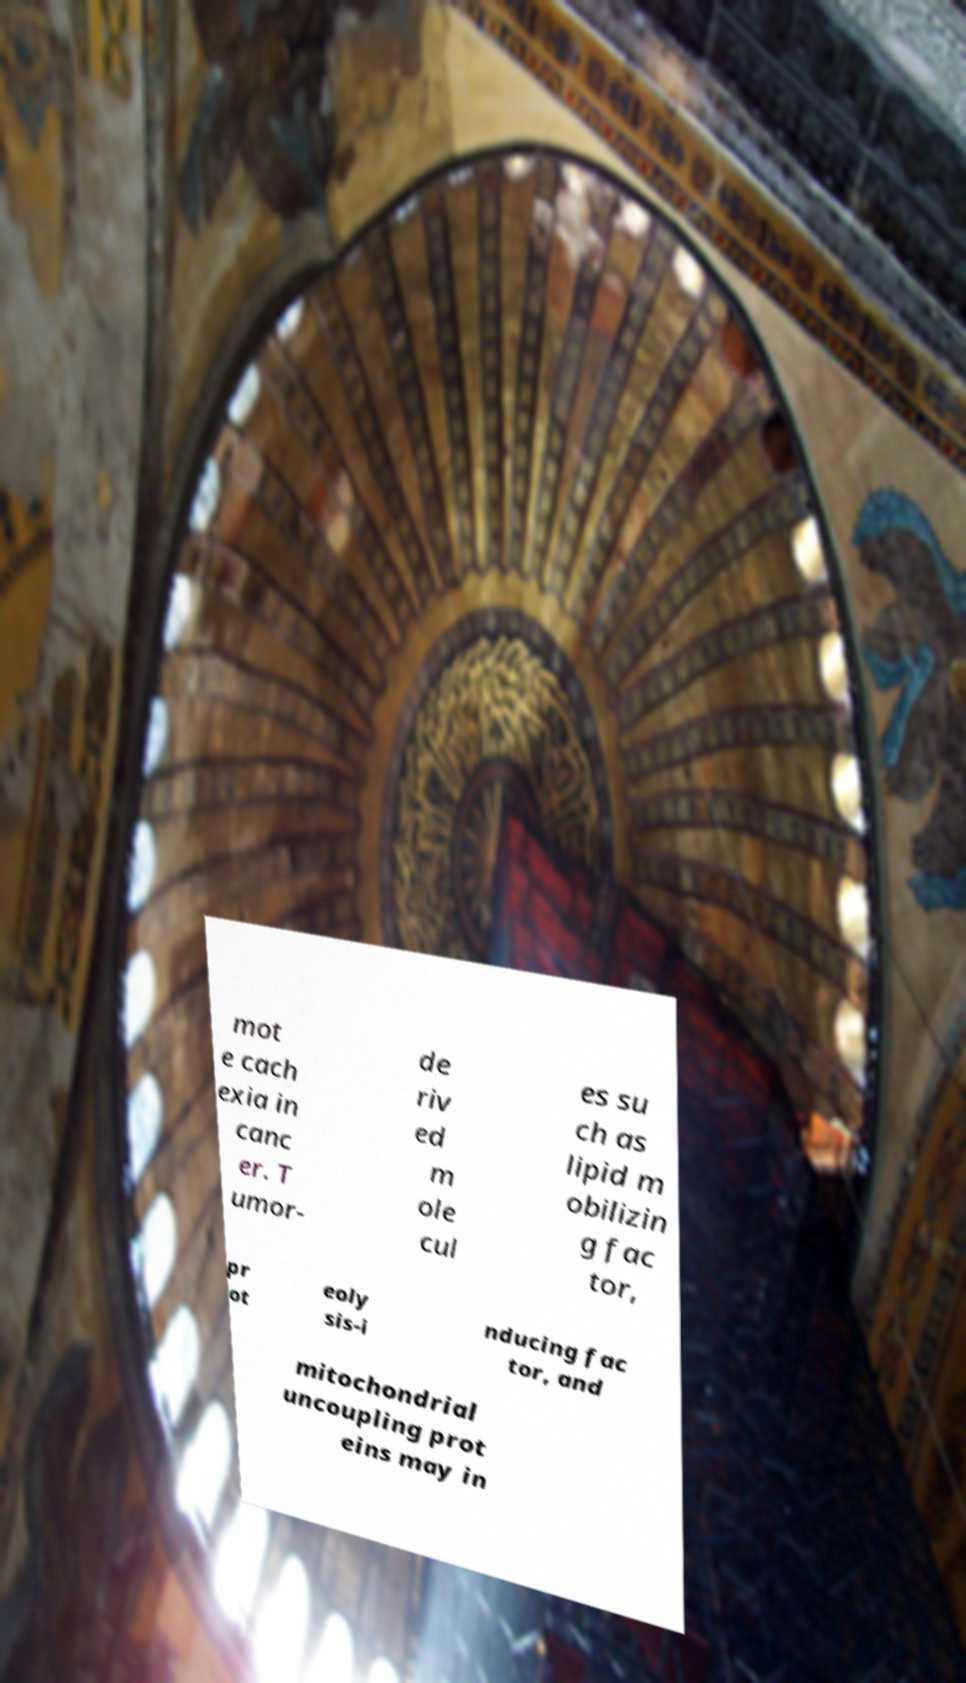Could you assist in decoding the text presented in this image and type it out clearly? mot e cach exia in canc er. T umor- de riv ed m ole cul es su ch as lipid m obilizin g fac tor, pr ot eoly sis-i nducing fac tor, and mitochondrial uncoupling prot eins may in 